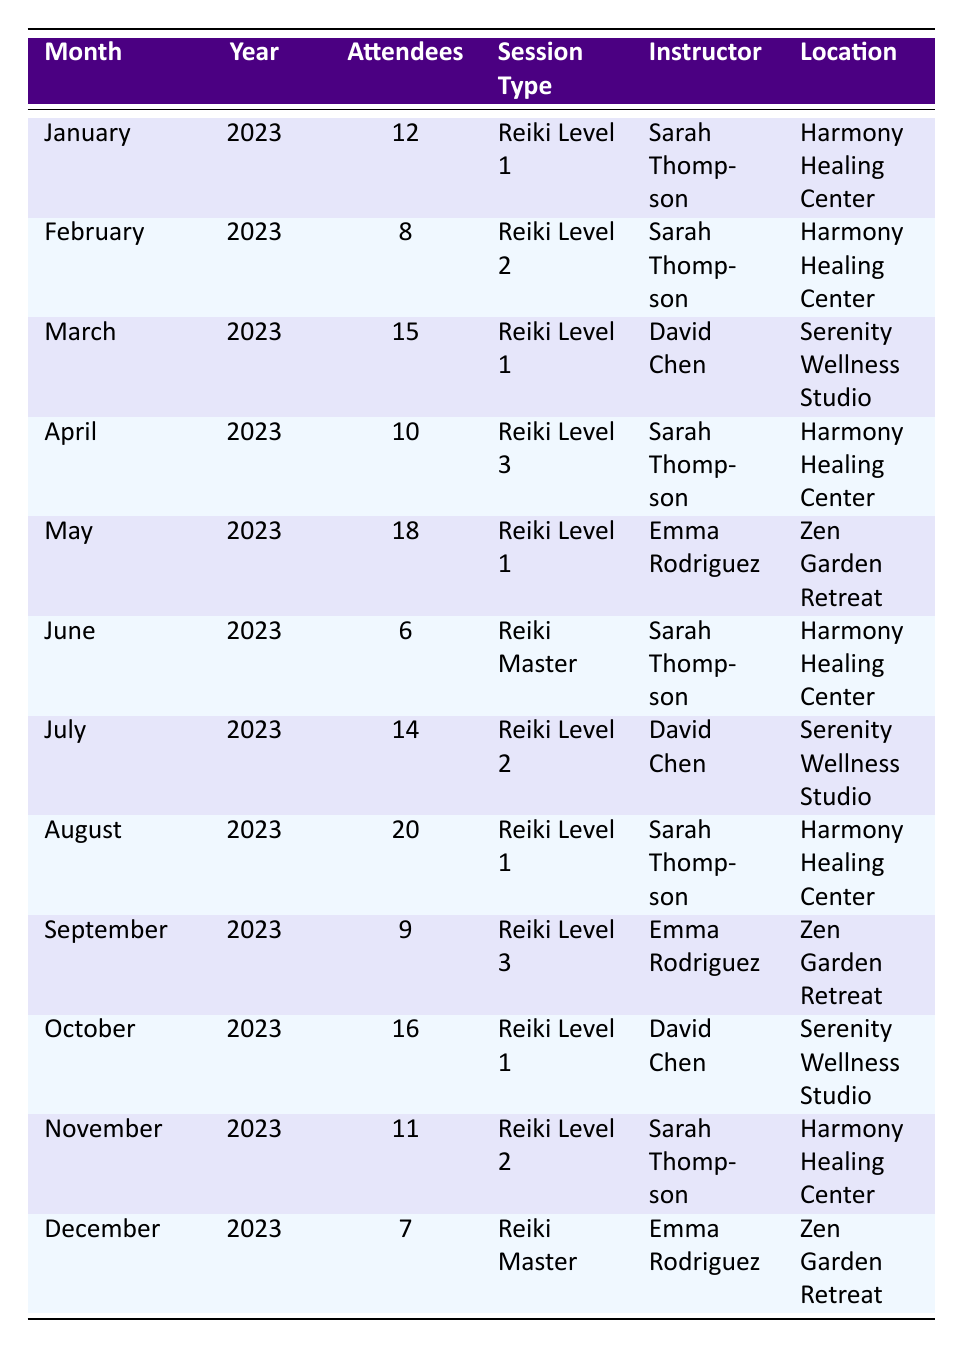What is the total number of attendees across all Reiki sessions in 2023? To find the total number of attendees, I need to sum the number of attendees for each month listed in the table: 12 + 8 + 15 + 10 + 18 + 6 + 14 + 20 + 9 + 16 + 11 + 7 =  236.
Answer: 236 Which month had the highest number of attendees? By examining the attendees for each month, the highest number of attendees is 20 in August.
Answer: August How many different types of Reiki sessions were held in 2023? The unique session types are Reiki Level 1, Reiki Level 2, Reiki Level 3, and Reiki Master. There are 4 different types.
Answer: 4 Did Sarah Thompson conduct a session in every month? Sarah Thompson taught sessions in January, February, April, June, July, and November, but she did not teach in March, May, August, September, October, or December. So, she did not conduct a session every month.
Answer: No What is the average attendance for Reiki Level 1 sessions? The months for Reiki Level 1 are January, March, May, August, and October, with attendance counts of 12, 15, 18, 20, and 16. The total is 12 + 15 + 18 + 20 + 16 = 81, and there are 5 sessions, so the average is 81/5 = 16.2.
Answer: 16.2 In which location did the least number of attendees occur? By checking the attendees per location, Harmony Healing Center has 6 attendees in June, which is the lowest number compared to other sessions.
Answer: Harmony Healing Center What fraction of the total attendance does the Reiki Master session represent? Total attendees is 236. The Reiki Master sessions had 6 attendees in June and 7 attendees in December, totaling 13. Thus, the fraction is 13/236, which simplifies to 1/18.154 or approximately 0.055.
Answer: 1/18.154 How many more attendees were there in August compared to June? August had 20 attendees, and June had 6 attendees. The difference is 20 - 6 = 14.
Answer: 14 What was the session type with the least attendance in November, and what was the count? In November, the session type was Reiki Level 2 with an attendance of 11, which is lesser compared to other months in that same category.
Answer: Reiki Level 2, 11 attendees Which instructor had the most sessions with the highest attendance, and what was the attendance? Sarah Thompson had two sessions with high attendance: 20 in August and 18 in May. The highest was 20 in August.
Answer: Sarah Thompson, 20 attendees in August How many sessions were conducted by David Chen and what was his average attendance? David Chen conducted three sessions (March, July, and October) with attendance of 15, 14, and 16, respectively. The total is 15 + 14 + 16 = 45, and the average is 45/3 = 15.
Answer: 3 sessions, average attendance 15 